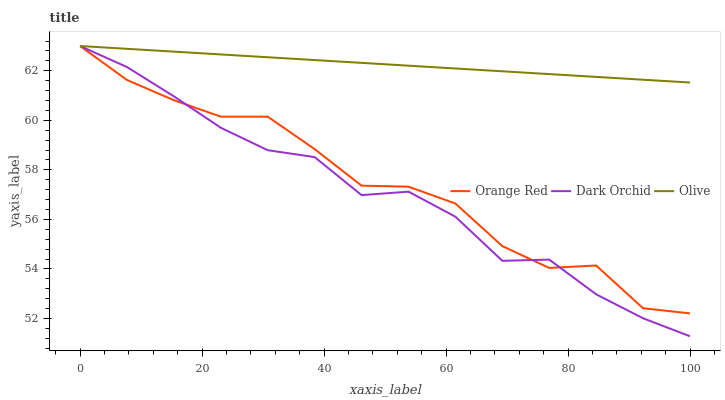Does Dark Orchid have the minimum area under the curve?
Answer yes or no. Yes. Does Olive have the maximum area under the curve?
Answer yes or no. Yes. Does Orange Red have the minimum area under the curve?
Answer yes or no. No. Does Orange Red have the maximum area under the curve?
Answer yes or no. No. Is Olive the smoothest?
Answer yes or no. Yes. Is Orange Red the roughest?
Answer yes or no. Yes. Is Dark Orchid the smoothest?
Answer yes or no. No. Is Dark Orchid the roughest?
Answer yes or no. No. Does Dark Orchid have the lowest value?
Answer yes or no. Yes. Does Orange Red have the lowest value?
Answer yes or no. No. Does Dark Orchid have the highest value?
Answer yes or no. Yes. Does Orange Red intersect Dark Orchid?
Answer yes or no. Yes. Is Orange Red less than Dark Orchid?
Answer yes or no. No. Is Orange Red greater than Dark Orchid?
Answer yes or no. No. 